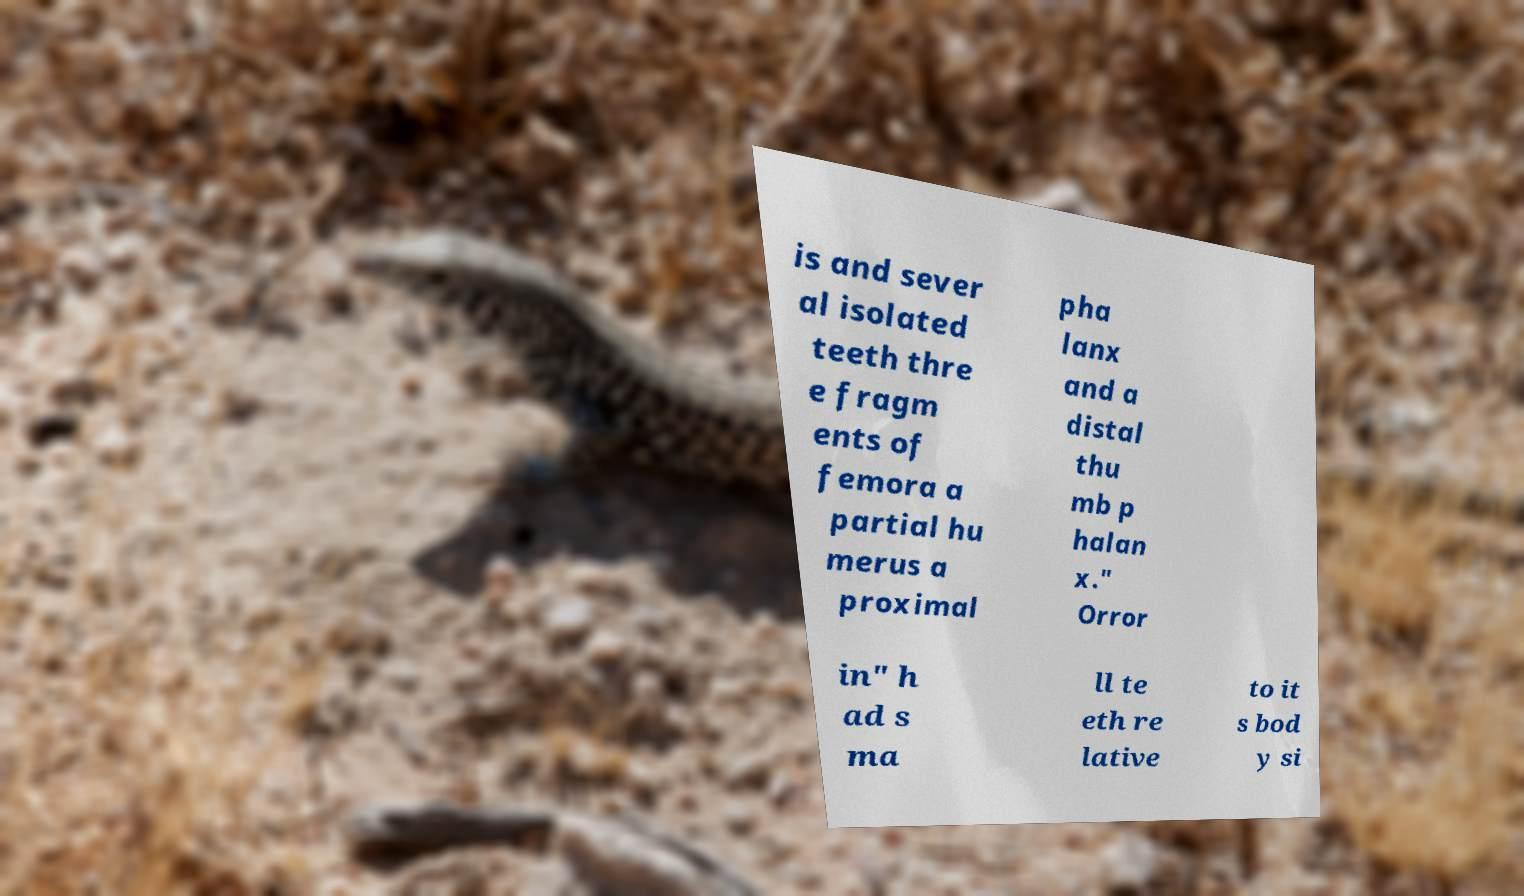Could you assist in decoding the text presented in this image and type it out clearly? is and sever al isolated teeth thre e fragm ents of femora a partial hu merus a proximal pha lanx and a distal thu mb p halan x." Orror in" h ad s ma ll te eth re lative to it s bod y si 